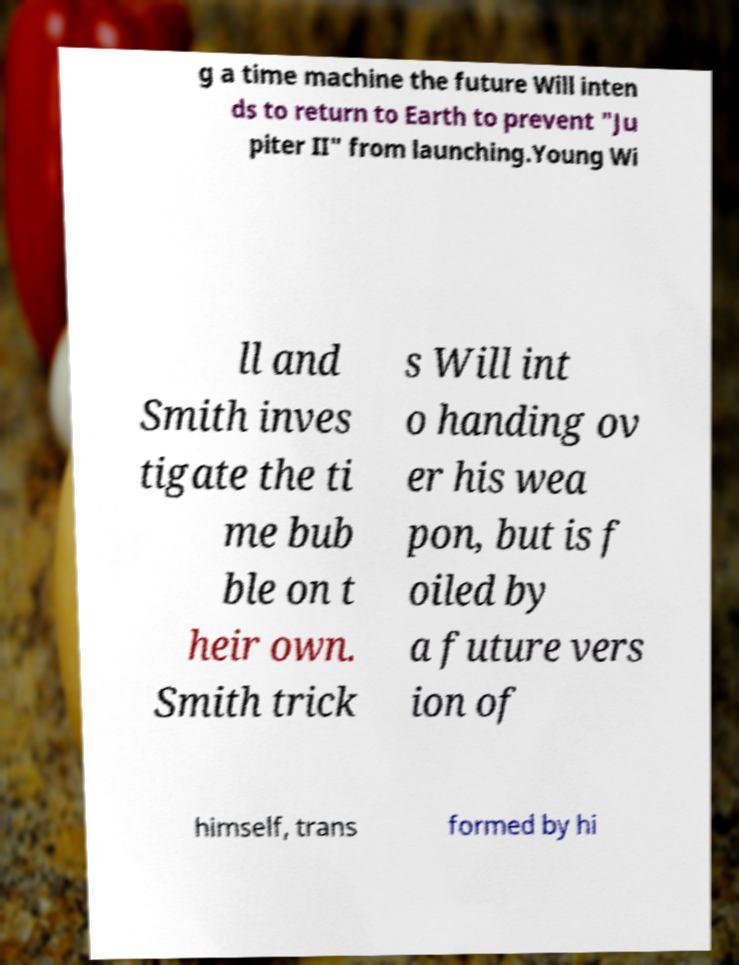Could you assist in decoding the text presented in this image and type it out clearly? g a time machine the future Will inten ds to return to Earth to prevent "Ju piter II" from launching.Young Wi ll and Smith inves tigate the ti me bub ble on t heir own. Smith trick s Will int o handing ov er his wea pon, but is f oiled by a future vers ion of himself, trans formed by hi 